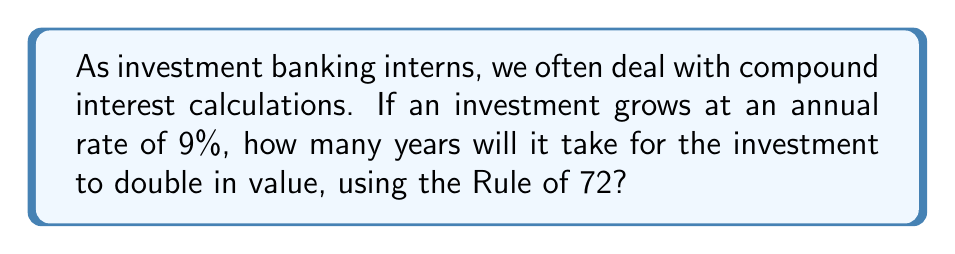Can you answer this question? Let's approach this step-by-step using the Rule of 72:

1) The Rule of 72 states that for an investment growing at a compound annual rate, the time it takes to double is approximately equal to 72 divided by the annual growth rate (expressed as a percentage).

2) The formula for the Rule of 72 is:

   $$ T \approx \frac{72}{r} $$

   Where:
   $T$ = Time to double (in years)
   $r$ = Annual growth rate (as a percentage)

3) In this case, we're given that the annual growth rate is 9%.

4) Let's plug this into our formula:

   $$ T \approx \frac{72}{9} $$

5) Now, let's solve:

   $$ T \approx 8 $$

6) Therefore, it will take approximately 8 years for the investment to double in value.

Note: The Rule of 72 is an approximation and works best for growth rates between 6% and 10%. For more precise calculations, especially outside this range, we would use the exact logarithmic formula:

$$ T = \frac{\ln(2)}{\ln(1 + \frac{r}{100})} $$

But for quick estimations in investment banking scenarios, the Rule of 72 is often sufficient.
Answer: 8 years 